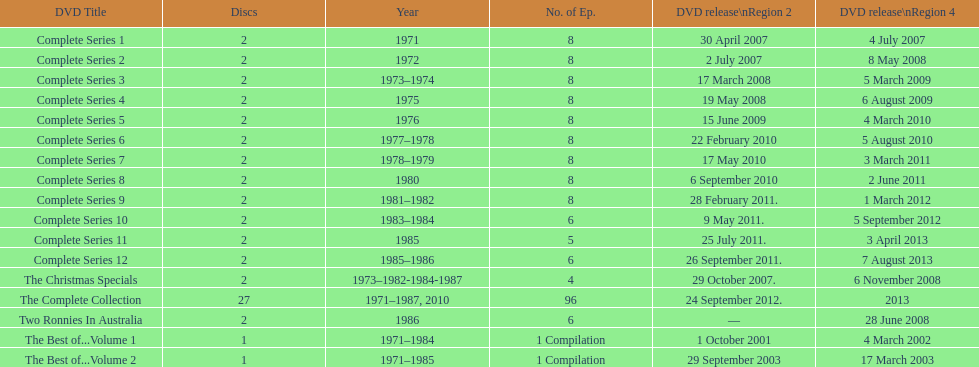What is previous to complete series 10? Complete Series 9. 